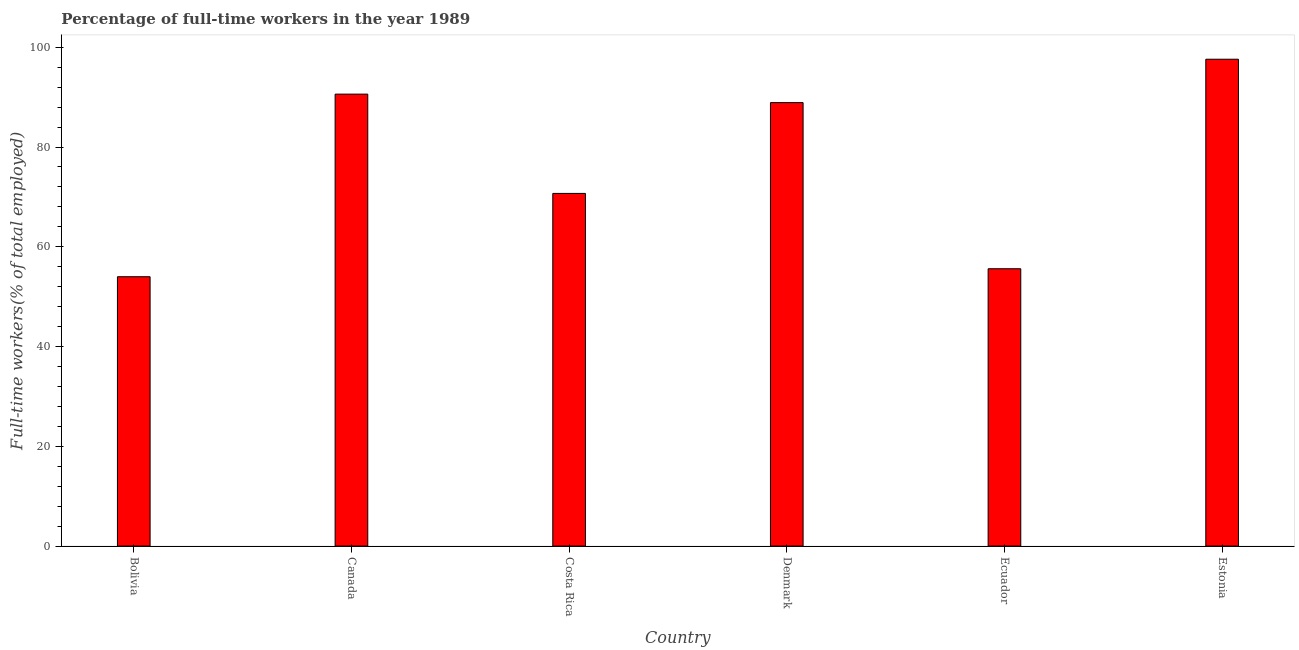What is the title of the graph?
Give a very brief answer. Percentage of full-time workers in the year 1989. What is the label or title of the Y-axis?
Give a very brief answer. Full-time workers(% of total employed). What is the percentage of full-time workers in Denmark?
Give a very brief answer. 88.9. Across all countries, what is the maximum percentage of full-time workers?
Your response must be concise. 97.6. Across all countries, what is the minimum percentage of full-time workers?
Ensure brevity in your answer.  54. In which country was the percentage of full-time workers maximum?
Your answer should be very brief. Estonia. What is the sum of the percentage of full-time workers?
Your response must be concise. 457.4. What is the difference between the percentage of full-time workers in Canada and Estonia?
Your answer should be compact. -7. What is the average percentage of full-time workers per country?
Provide a short and direct response. 76.23. What is the median percentage of full-time workers?
Your response must be concise. 79.8. In how many countries, is the percentage of full-time workers greater than 44 %?
Offer a very short reply. 6. What is the ratio of the percentage of full-time workers in Denmark to that in Ecuador?
Make the answer very short. 1.6. Is the percentage of full-time workers in Costa Rica less than that in Ecuador?
Ensure brevity in your answer.  No. What is the difference between the highest and the lowest percentage of full-time workers?
Provide a short and direct response. 43.6. In how many countries, is the percentage of full-time workers greater than the average percentage of full-time workers taken over all countries?
Provide a succinct answer. 3. How many bars are there?
Your answer should be very brief. 6. Are all the bars in the graph horizontal?
Provide a short and direct response. No. How many countries are there in the graph?
Offer a terse response. 6. What is the difference between two consecutive major ticks on the Y-axis?
Make the answer very short. 20. What is the Full-time workers(% of total employed) of Canada?
Provide a short and direct response. 90.6. What is the Full-time workers(% of total employed) in Costa Rica?
Offer a very short reply. 70.7. What is the Full-time workers(% of total employed) of Denmark?
Give a very brief answer. 88.9. What is the Full-time workers(% of total employed) in Ecuador?
Your response must be concise. 55.6. What is the Full-time workers(% of total employed) in Estonia?
Your answer should be very brief. 97.6. What is the difference between the Full-time workers(% of total employed) in Bolivia and Canada?
Give a very brief answer. -36.6. What is the difference between the Full-time workers(% of total employed) in Bolivia and Costa Rica?
Give a very brief answer. -16.7. What is the difference between the Full-time workers(% of total employed) in Bolivia and Denmark?
Keep it short and to the point. -34.9. What is the difference between the Full-time workers(% of total employed) in Bolivia and Ecuador?
Keep it short and to the point. -1.6. What is the difference between the Full-time workers(% of total employed) in Bolivia and Estonia?
Your answer should be very brief. -43.6. What is the difference between the Full-time workers(% of total employed) in Canada and Denmark?
Make the answer very short. 1.7. What is the difference between the Full-time workers(% of total employed) in Canada and Ecuador?
Your answer should be very brief. 35. What is the difference between the Full-time workers(% of total employed) in Costa Rica and Denmark?
Your response must be concise. -18.2. What is the difference between the Full-time workers(% of total employed) in Costa Rica and Ecuador?
Make the answer very short. 15.1. What is the difference between the Full-time workers(% of total employed) in Costa Rica and Estonia?
Give a very brief answer. -26.9. What is the difference between the Full-time workers(% of total employed) in Denmark and Ecuador?
Give a very brief answer. 33.3. What is the difference between the Full-time workers(% of total employed) in Ecuador and Estonia?
Provide a short and direct response. -42. What is the ratio of the Full-time workers(% of total employed) in Bolivia to that in Canada?
Keep it short and to the point. 0.6. What is the ratio of the Full-time workers(% of total employed) in Bolivia to that in Costa Rica?
Your response must be concise. 0.76. What is the ratio of the Full-time workers(% of total employed) in Bolivia to that in Denmark?
Give a very brief answer. 0.61. What is the ratio of the Full-time workers(% of total employed) in Bolivia to that in Ecuador?
Your answer should be compact. 0.97. What is the ratio of the Full-time workers(% of total employed) in Bolivia to that in Estonia?
Your answer should be very brief. 0.55. What is the ratio of the Full-time workers(% of total employed) in Canada to that in Costa Rica?
Ensure brevity in your answer.  1.28. What is the ratio of the Full-time workers(% of total employed) in Canada to that in Denmark?
Ensure brevity in your answer.  1.02. What is the ratio of the Full-time workers(% of total employed) in Canada to that in Ecuador?
Provide a succinct answer. 1.63. What is the ratio of the Full-time workers(% of total employed) in Canada to that in Estonia?
Your answer should be very brief. 0.93. What is the ratio of the Full-time workers(% of total employed) in Costa Rica to that in Denmark?
Your answer should be very brief. 0.8. What is the ratio of the Full-time workers(% of total employed) in Costa Rica to that in Ecuador?
Make the answer very short. 1.27. What is the ratio of the Full-time workers(% of total employed) in Costa Rica to that in Estonia?
Your answer should be compact. 0.72. What is the ratio of the Full-time workers(% of total employed) in Denmark to that in Ecuador?
Make the answer very short. 1.6. What is the ratio of the Full-time workers(% of total employed) in Denmark to that in Estonia?
Ensure brevity in your answer.  0.91. What is the ratio of the Full-time workers(% of total employed) in Ecuador to that in Estonia?
Provide a succinct answer. 0.57. 